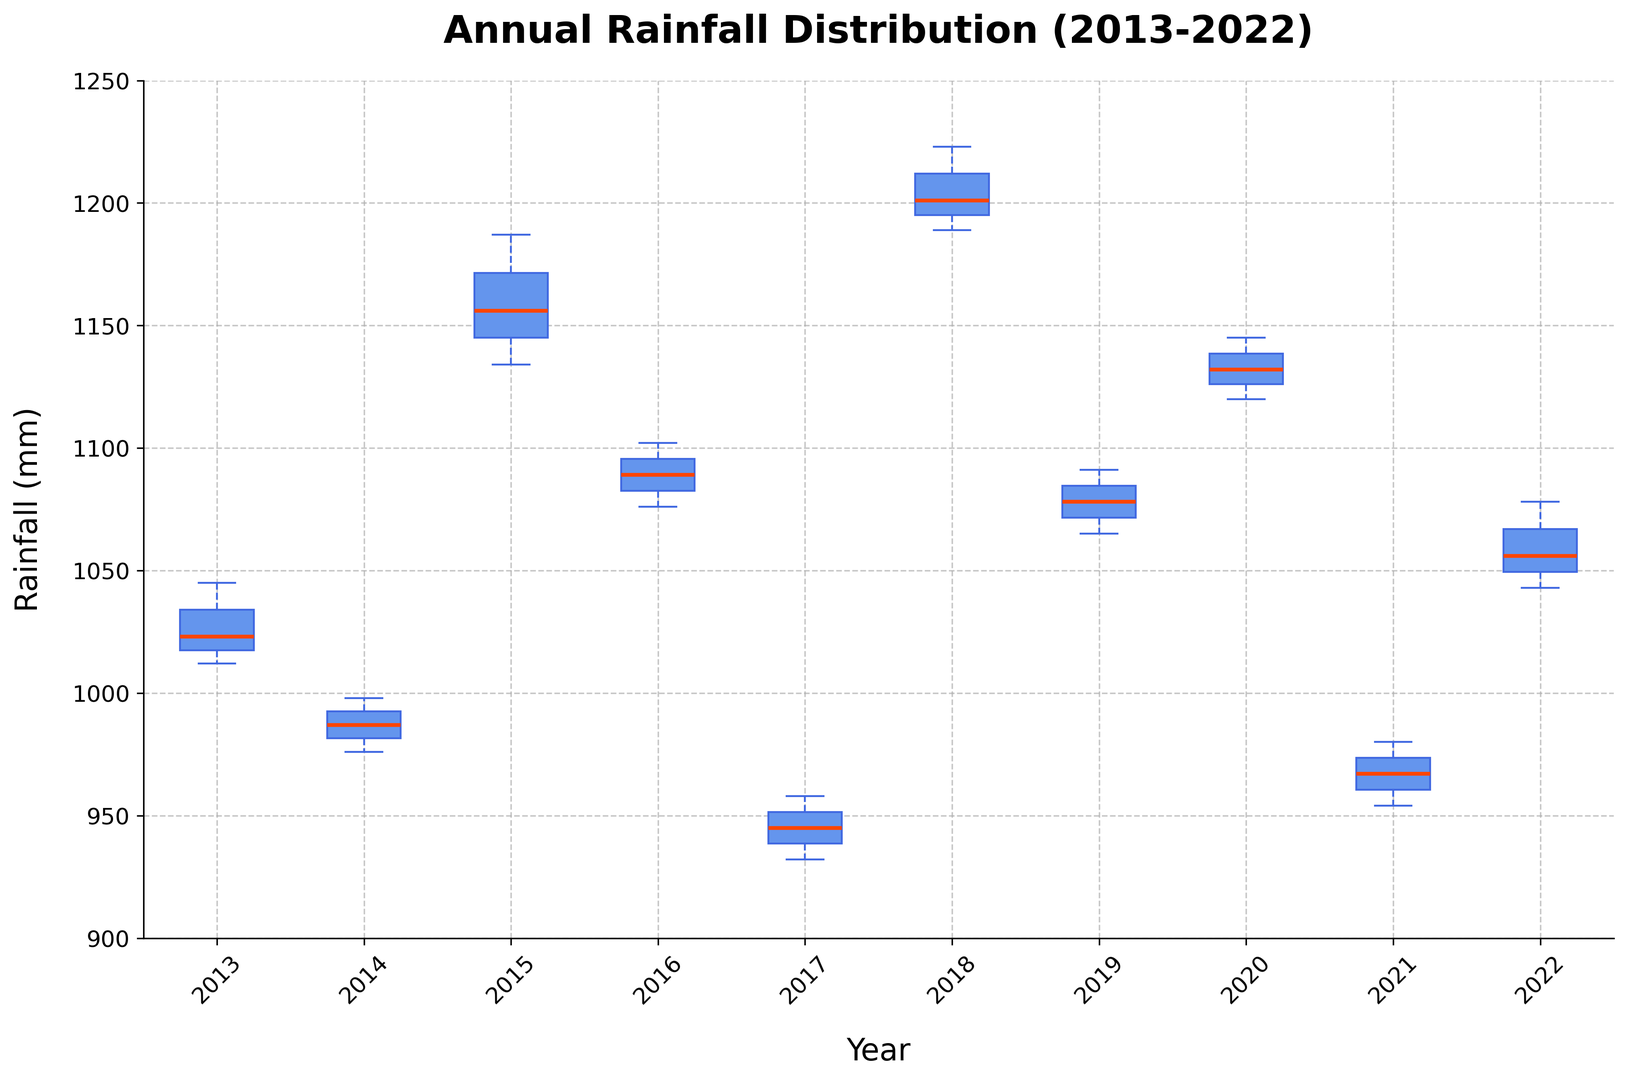How many years have a median rainfall amount greater than 1100 mm? To determine this, look at the median line within each box of the box plot and count how many of those lines are above the 1100 mm mark on the y-axis.
Answer: 4 Which year has the highest maximum rainfall outlier? Locate the highest point above the whiskers for each year, often represented by a dot. The year with the dot at the highest vertical position is the one with the highest maximum outlier.
Answer: 2018 During which year is the interquartile range (IQR) the smallest? The IQR is represented by the height of the box from the lower quartile (bottom edge) to the upper quartile (top edge). Identify which year's box is the shortest vertically.
Answer: 2014 Which year shows the most variability in annual rainfall? Variability can be seen by the overall height of the data range, including the distance between the whiskers and the length of the box. Look for the year with the longest vertical range from the bottom whisker to the top whisker.
Answer: 2018 Compare the median rainfall in 2015 and 2021. Which year has a higher median? Look at the median lines within the boxes for 2015 and 2021. Identify which one is positioned higher on the y-axis.
Answer: 2015 What is the range of the rainfall for the year 2016? The range is the distance between the top of the upper whisker and the bottom of the lower whisker. Find these points for 2016 and calculate the difference.
Answer: Approximately 1040 mm - 1190 mm = 150 mm Between 2019 and 2020, which year exhibits a lower minimum rainfall value? Examine the bottom whiskers for both 2019 and 2020 and determine which one is lower on the y-axis.
Answer: 2019 What is the median rainfall in 2018 and how does it compare to the median in 2014? Identify the median lines within the boxes for 2018 and 2014 and compare their positions.
Answer: 2018 has a higher median than 2014 Is there any year where the entire range of data is above 1000 mm? Look for years where the bottom of the lower whisker is above 1000 mm.
Answer: No In which year is the median rainfall very close to the Q3 value, indicating a skewed distribution? Identify the box where the median line is very close to the top edge of the box (Q3).
Answer: 2019 